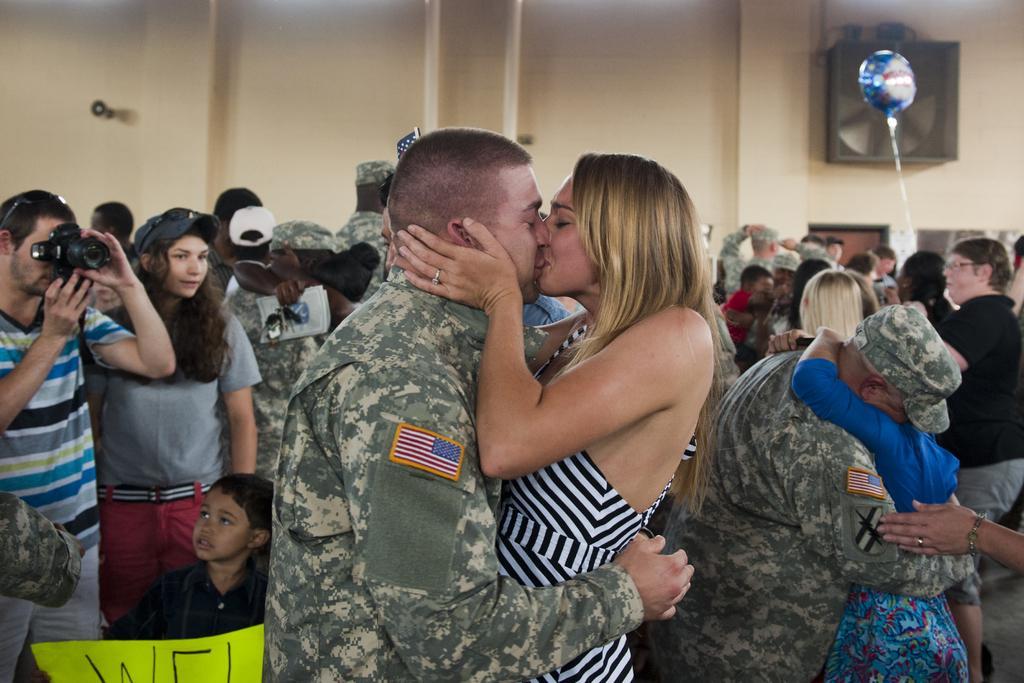Could you give a brief overview of what you see in this image? In the picture I can see people are standing among them the man and the woman in front of the image are kissing each other. On the left side of the image I can see a person is holding a camera in hands. In the background I can see a balloon, wall and some other objects. 